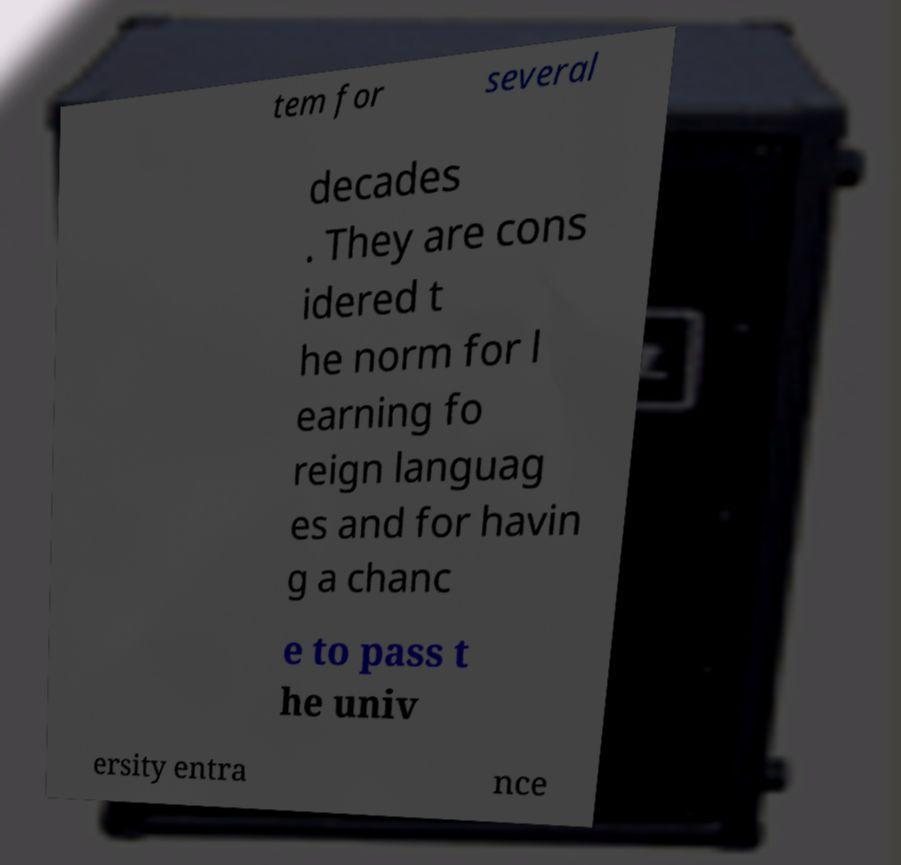Please read and relay the text visible in this image. What does it say? tem for several decades . They are cons idered t he norm for l earning fo reign languag es and for havin g a chanc e to pass t he univ ersity entra nce 